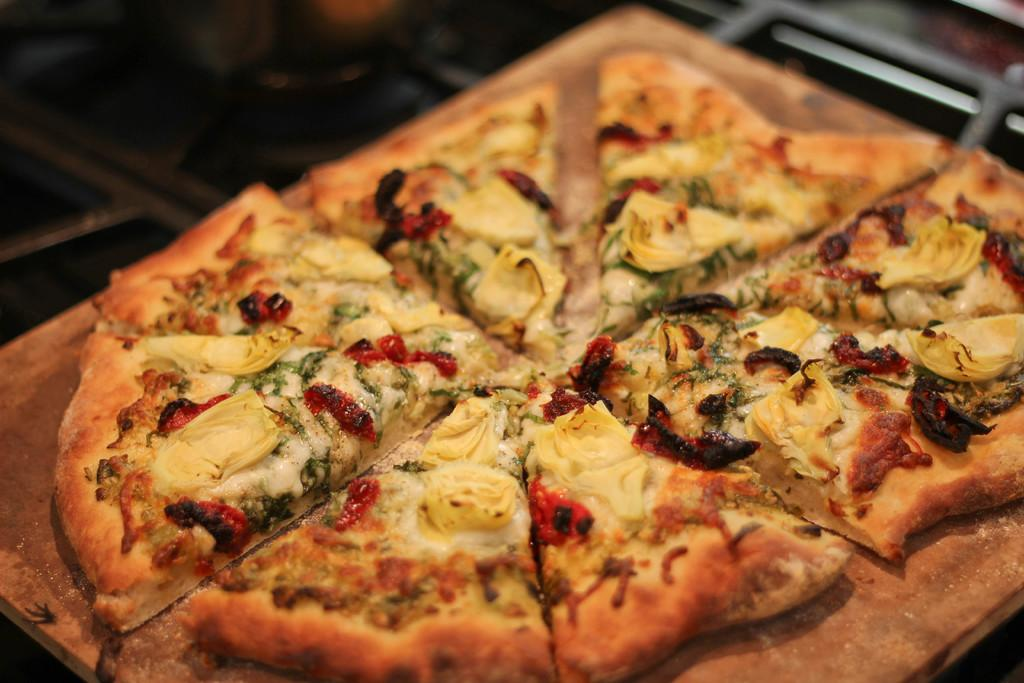What type of food can be seen in the image? There are pieces of pizza in the image. What material is the surface on which the pizza is placed? The wooden surface is visible in the image. Can you describe the background of the image? The background of the image is blurry. What type of farm animals can be seen on the page in the image? There is no page or farm animals present in the image; it features pieces of pizza on a wooden surface with a blurry background. 